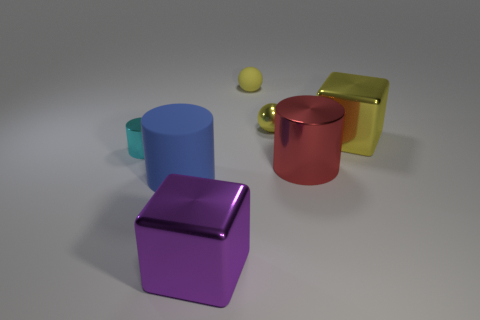Subtract all red cylinders. How many cylinders are left? 2 Subtract 1 cylinders. How many cylinders are left? 2 Add 2 brown metallic things. How many objects exist? 9 Subtract all brown cubes. Subtract all purple cylinders. How many cubes are left? 2 Subtract 0 brown spheres. How many objects are left? 7 Subtract all cubes. How many objects are left? 5 Subtract all small blue metal spheres. Subtract all blue matte things. How many objects are left? 6 Add 5 tiny yellow objects. How many tiny yellow objects are left? 7 Add 6 tiny cyan shiny cylinders. How many tiny cyan shiny cylinders exist? 7 